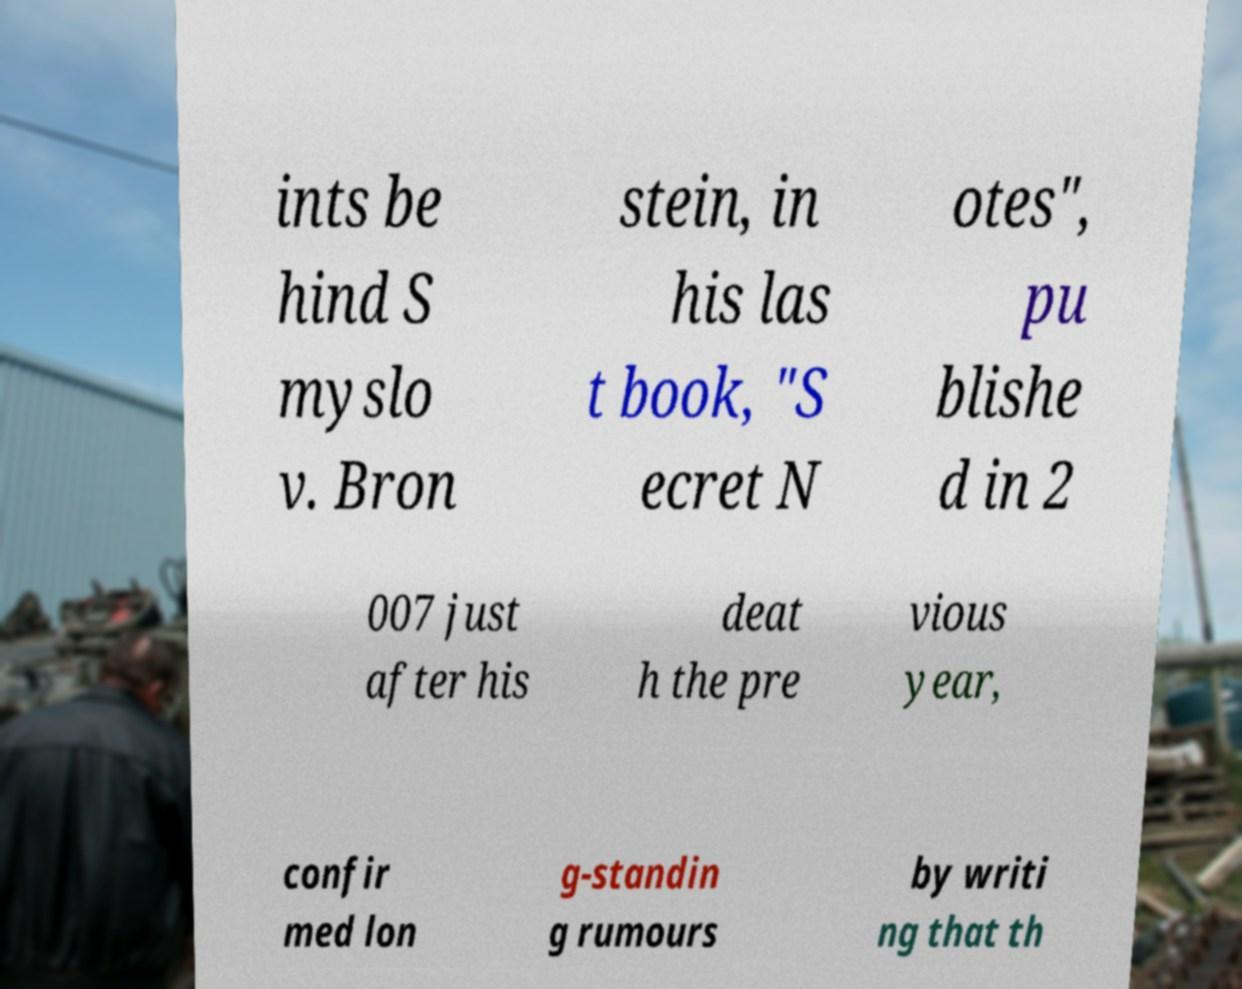Can you read and provide the text displayed in the image?This photo seems to have some interesting text. Can you extract and type it out for me? ints be hind S myslo v. Bron stein, in his las t book, "S ecret N otes", pu blishe d in 2 007 just after his deat h the pre vious year, confir med lon g-standin g rumours by writi ng that th 